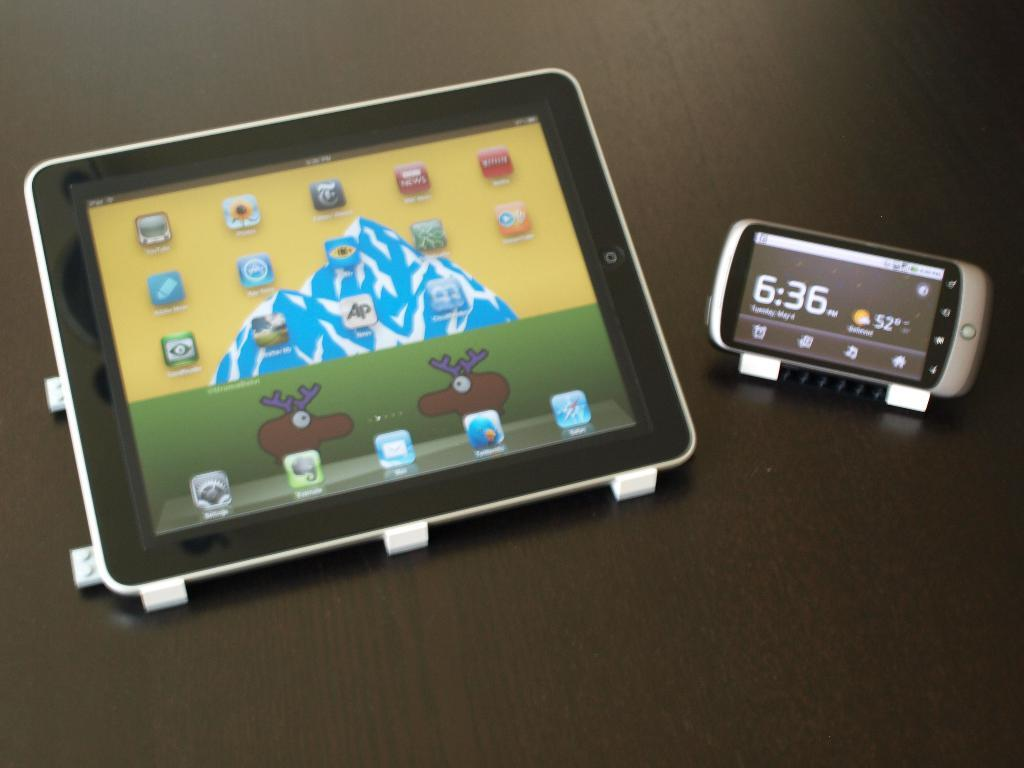What electronic device is visible in the image? There is a tablet in the image. What other electronic device can be seen in the image? There is a mobile phone in the image. On what surface are the tablet and mobile phone placed? The tablet and mobile phone are on a surface that resembles a table. What type of square object is buzzing around the tablet in the image? There is no square object buzzing around the tablet in the image. What type of surprise can be seen on the mobile phone in the image? There is no surprise present on the mobile phone in the image. 